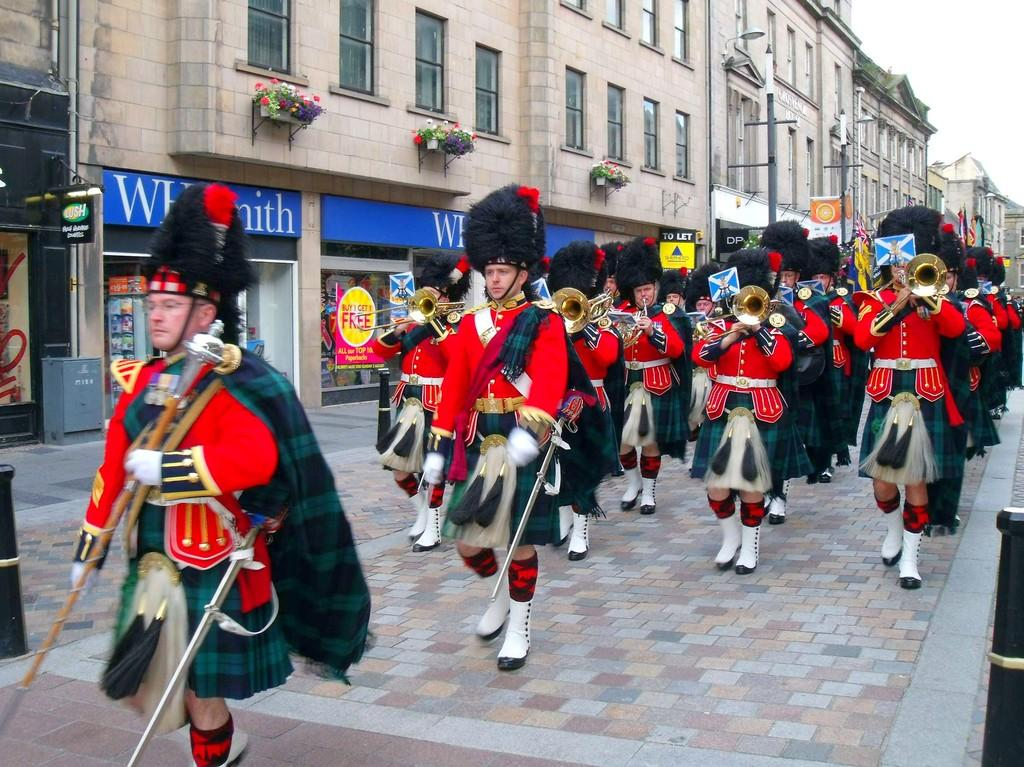What are the people in the image doing? The people in the image are holding musical instruments. Are the people in the image stationary or moving? The people are walking. What type of structures can be seen in the image? There are buildings in the image. What object is present in the image that is not a building or a person? There is a pole in the image. What type of vegetation is visible in the image? There are flower plants in the image. What time is displayed on the flag in the image? There is no flag present in the image, so it is not possible to determine the time displayed on it. What type of rod is being used by the people in the image? The people in the image are holding musical instruments, not rods. 